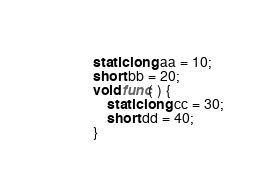<code> <loc_0><loc_0><loc_500><loc_500><_C_>static long aa = 10;
short bb = 20;
void func( ) {
    static long cc = 30;
    short dd = 40;
}

</code> 